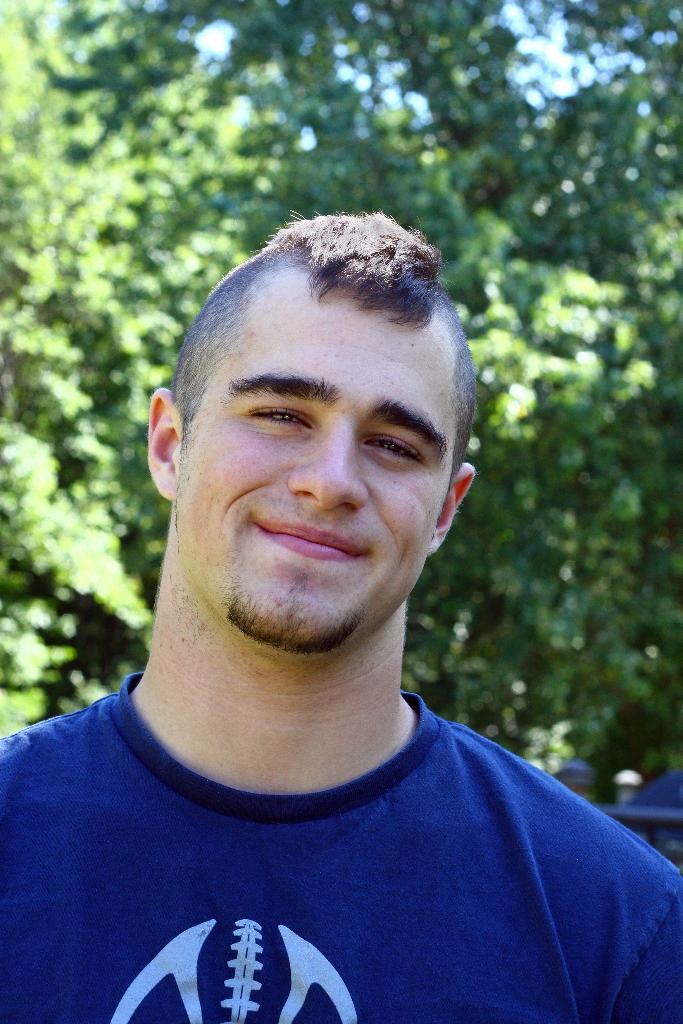Could you give a brief overview of what you see in this image? In this image there is a man in blue t-shirt is standing and smiling behind him there are so many trees. 